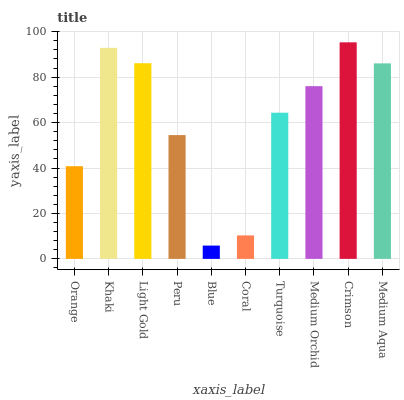Is Blue the minimum?
Answer yes or no. Yes. Is Crimson the maximum?
Answer yes or no. Yes. Is Khaki the minimum?
Answer yes or no. No. Is Khaki the maximum?
Answer yes or no. No. Is Khaki greater than Orange?
Answer yes or no. Yes. Is Orange less than Khaki?
Answer yes or no. Yes. Is Orange greater than Khaki?
Answer yes or no. No. Is Khaki less than Orange?
Answer yes or no. No. Is Medium Orchid the high median?
Answer yes or no. Yes. Is Turquoise the low median?
Answer yes or no. Yes. Is Blue the high median?
Answer yes or no. No. Is Peru the low median?
Answer yes or no. No. 